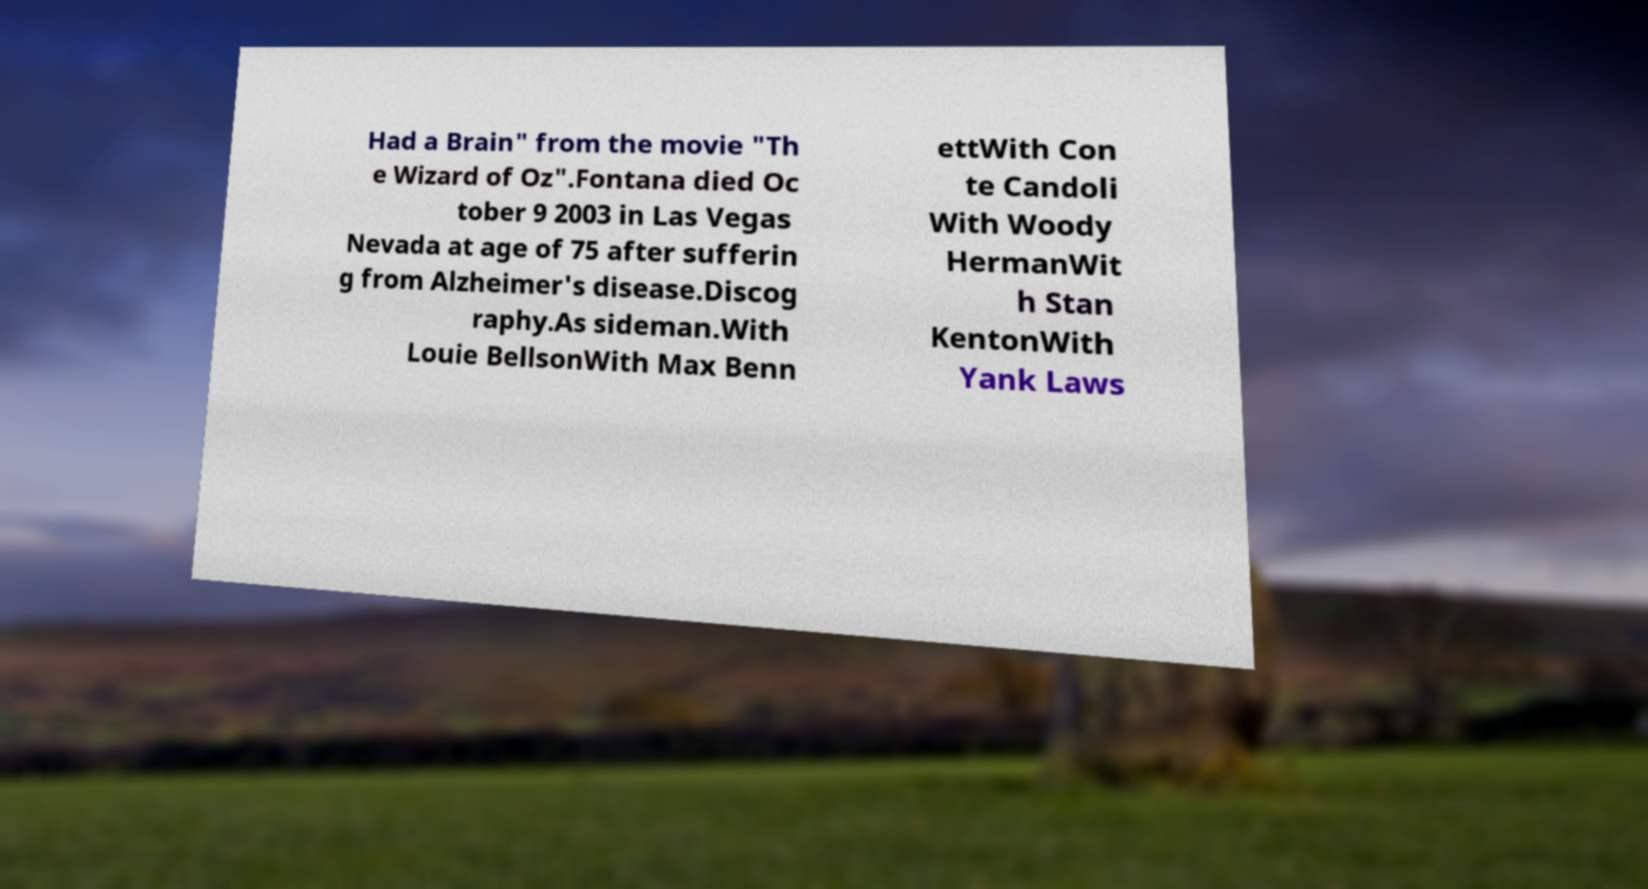Please read and relay the text visible in this image. What does it say? Had a Brain" from the movie "Th e Wizard of Oz".Fontana died Oc tober 9 2003 in Las Vegas Nevada at age of 75 after sufferin g from Alzheimer's disease.Discog raphy.As sideman.With Louie BellsonWith Max Benn ettWith Con te Candoli With Woody HermanWit h Stan KentonWith Yank Laws 